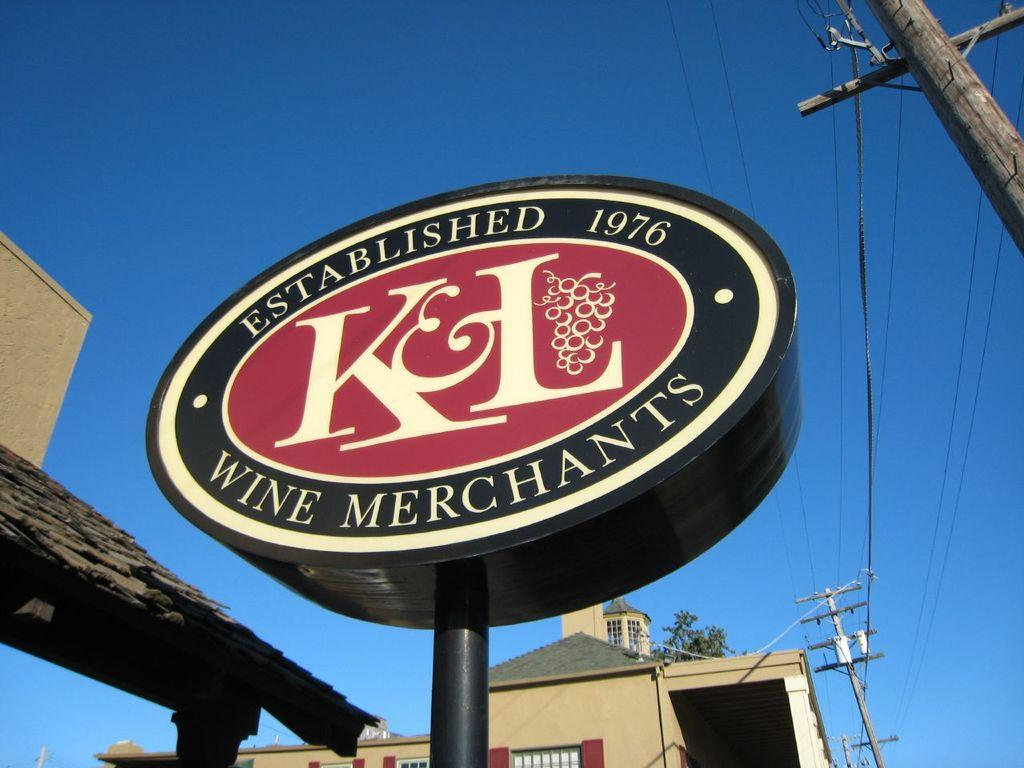What structures can be seen in the image? There are poles, a board, and a rooftop in the image. What else is present in the image besides the structures? There are wires, a house, leaves, and the sky visible in the image. Can you describe the sky in the image? The sky is visible in the background of the image, and its color is blue. What type of locket can be seen hanging from the pole in the image? There is no locket present in the image; only poles, a board, wires, a house, leaves, and the sky are visible. What store is located near the house in the image? There is no store mentioned or visible in the image; it only features a house, poles, a board, wires, leaves, and the sky. 